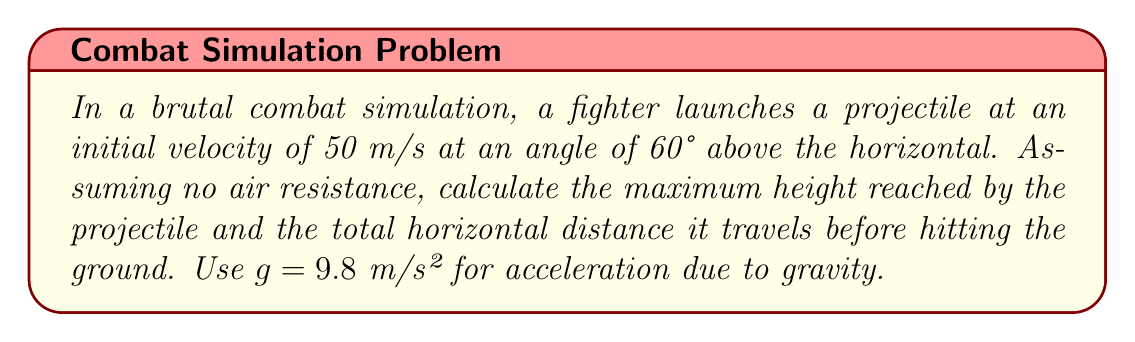What is the answer to this math problem? 1. The trajectory of the projectile follows a quadratic function. We'll use the equations:

   Vertical motion: $y = y_0 + v_0\sin(\theta)t - \frac{1}{2}gt^2$
   Horizontal motion: $x = v_0\cos(\theta)t$

   Where $v_0 = 50$ m/s, $\theta = 60°$, and $g = 9.8$ m/s².

2. For maximum height:
   a. Find time to reach max height: $t_{max} = \frac{v_0\sin(\theta)}{g}$
      $t_{max} = \frac{50 \sin(60°)}{9.8} = 4.42$ s

   b. Calculate max height: $h_{max} = v_0\sin(\theta)t_{max} - \frac{1}{2}gt_{max}^2$
      $h_{max} = 50 \sin(60°) \cdot 4.42 - \frac{1}{2} \cdot 9.8 \cdot 4.42^2 = 95.1$ m

3. For total horizontal distance:
   a. Find time of flight: $t_{flight} = \frac{2v_0\sin(\theta)}{g} = 2t_{max} = 8.84$ s

   b. Calculate distance: $d = v_0\cos(\theta)t_{flight}$
      $d = 50 \cos(60°) \cdot 8.84 = 220.9$ m
Answer: Maximum height: 95.1 m; Total horizontal distance: 220.9 m 